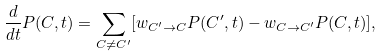<formula> <loc_0><loc_0><loc_500><loc_500>\frac { d } { d t } P ( C , t ) = \sum _ { C \neq C ^ { \prime } } [ w _ { C ^ { \prime } \to C } P ( C ^ { \prime } , t ) - w _ { C \to C ^ { \prime } } P ( C , t ) ] ,</formula> 